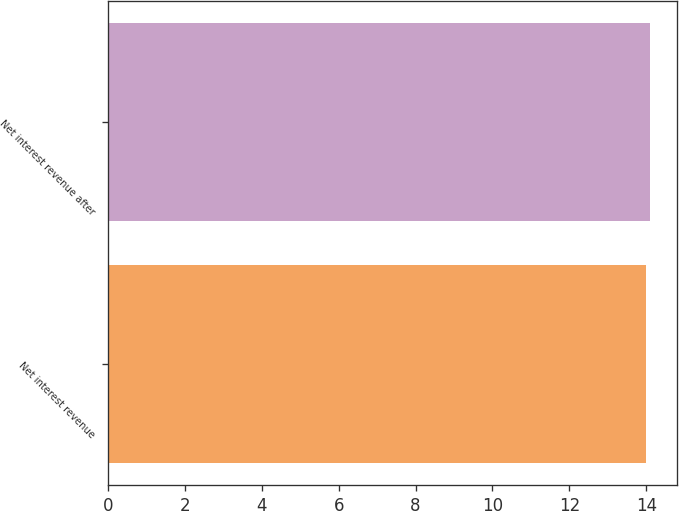Convert chart to OTSL. <chart><loc_0><loc_0><loc_500><loc_500><bar_chart><fcel>Net interest revenue<fcel>Net interest revenue after<nl><fcel>14<fcel>14.1<nl></chart> 